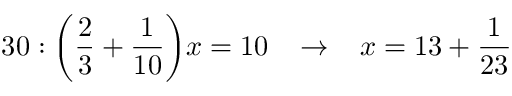Convert formula to latex. <formula><loc_0><loc_0><loc_500><loc_500>3 0 \colon { \left ( } { \frac { 2 } { 3 } } + { \frac { 1 } { 1 0 } } { \right ) } x = 1 0 \, \rightarrow \, x = 1 3 + { \frac { 1 } { 2 3 } }</formula> 